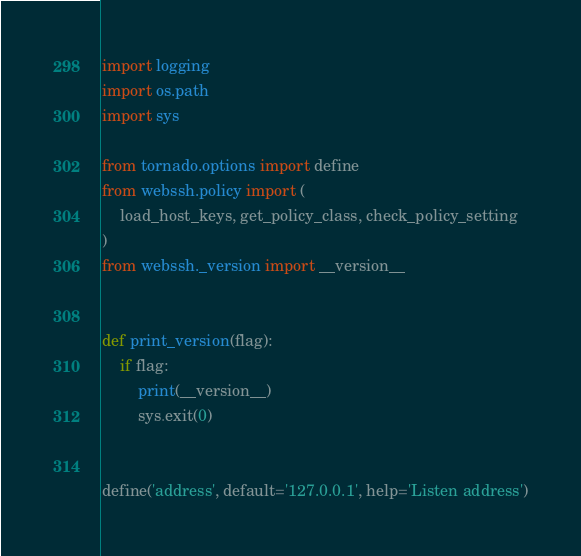<code> <loc_0><loc_0><loc_500><loc_500><_Python_>import logging
import os.path
import sys

from tornado.options import define
from webssh.policy import (
    load_host_keys, get_policy_class, check_policy_setting
)
from webssh._version import __version__


def print_version(flag):
    if flag:
        print(__version__)
        sys.exit(0)


define('address', default='127.0.0.1', help='Listen address')</code> 